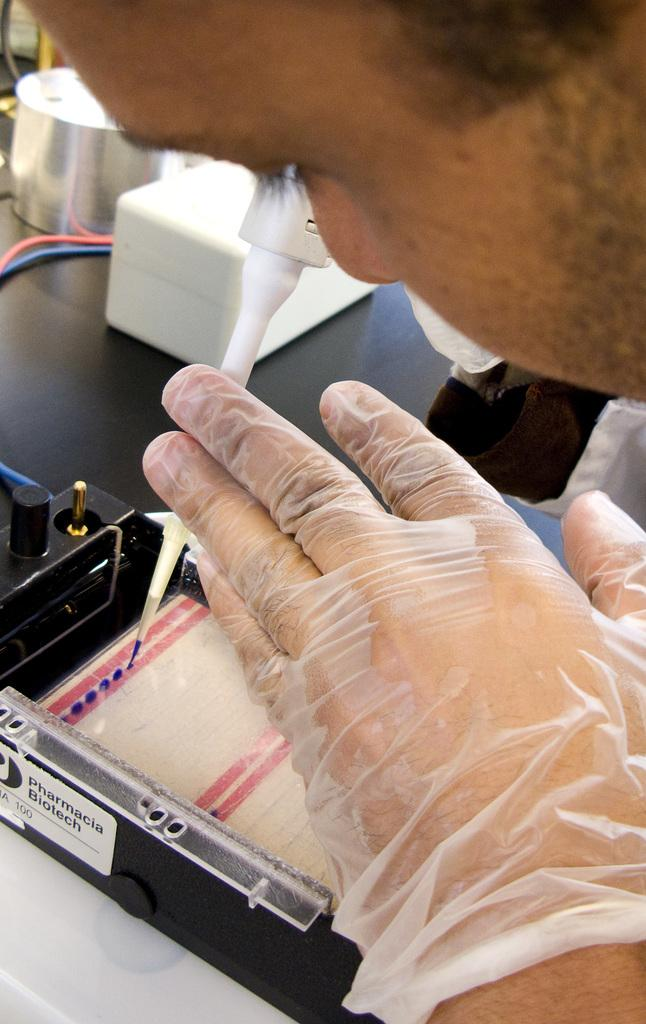What can be seen in the image? There is a person in the image. What is the person wearing on their hands? The person is wearing transparent gloves on their hands. What is the person holding in the image? The person is holding an equipment. Where is the equipment located? The equipment is on a table. What type of oatmeal is being served in the lunchroom in the image? There is no lunchroom or oatmeal present in the image. What type of stitch is the person using to sew in the image? The image does not show any sewing or stitching activity, nor is there any equipment that would suggest such an activity. 